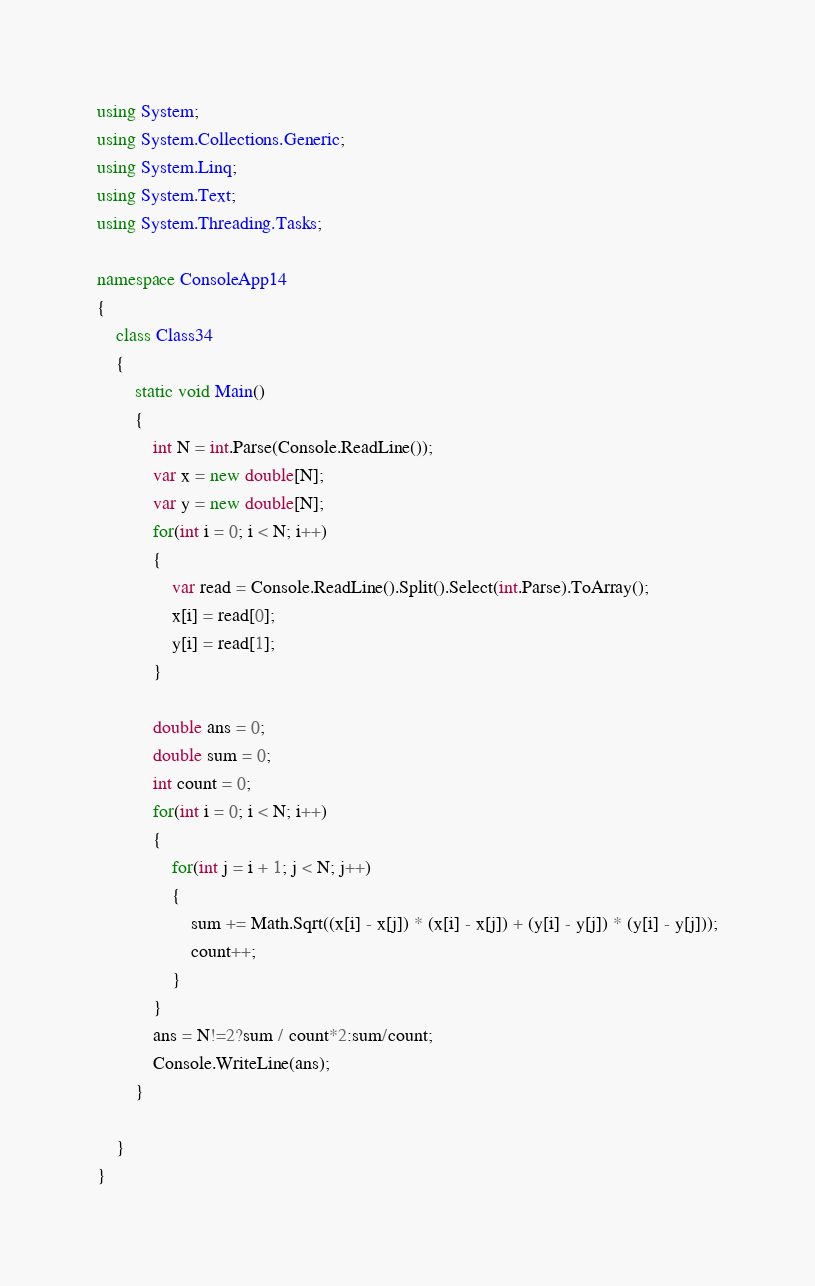Convert code to text. <code><loc_0><loc_0><loc_500><loc_500><_C#_>using System;
using System.Collections.Generic;
using System.Linq;
using System.Text;
using System.Threading.Tasks;

namespace ConsoleApp14
{
    class Class34
    {
        static void Main()
        {
            int N = int.Parse(Console.ReadLine());
            var x = new double[N];
            var y = new double[N];
            for(int i = 0; i < N; i++)
            {
                var read = Console.ReadLine().Split().Select(int.Parse).ToArray();
                x[i] = read[0];
                y[i] = read[1];
            }

            double ans = 0;
            double sum = 0;
            int count = 0;
            for(int i = 0; i < N; i++)
            {
                for(int j = i + 1; j < N; j++)
                {
                    sum += Math.Sqrt((x[i] - x[j]) * (x[i] - x[j]) + (y[i] - y[j]) * (y[i] - y[j]));
                    count++;
                }
            }
            ans = N!=2?sum / count*2:sum/count;
            Console.WriteLine(ans);
        }
        
    }
}
</code> 